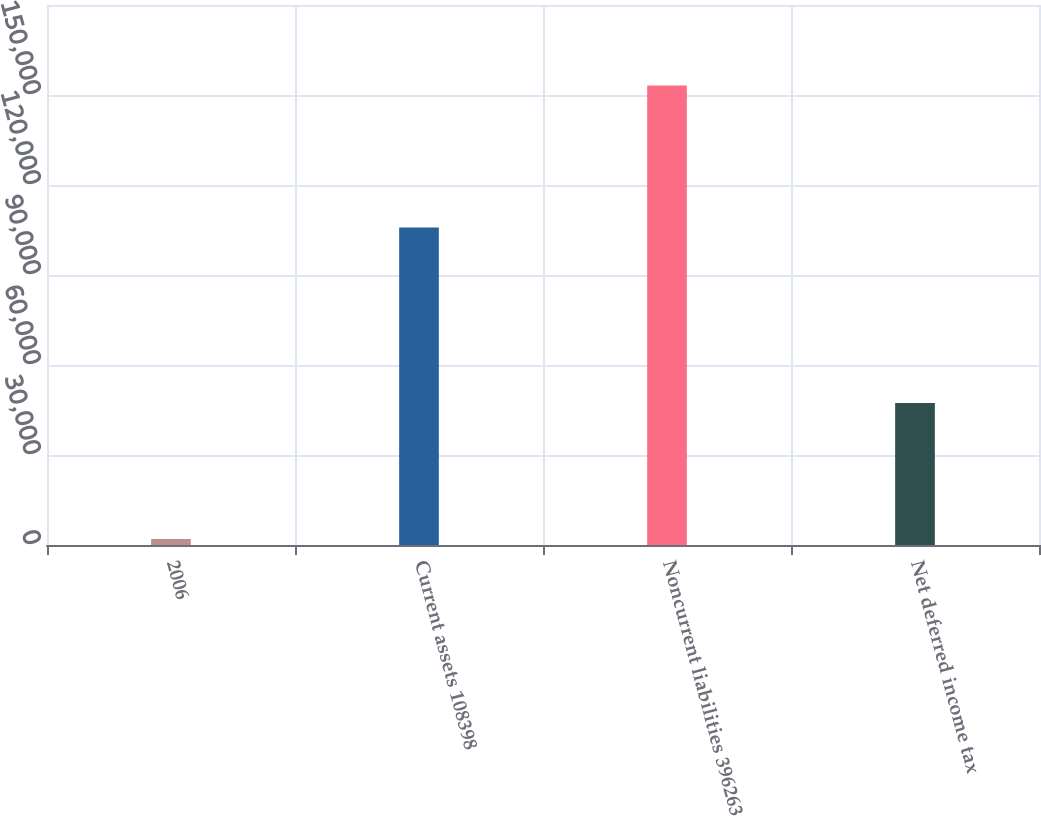<chart> <loc_0><loc_0><loc_500><loc_500><bar_chart><fcel>2006<fcel>Current assets 108398<fcel>Noncurrent liabilities 396263<fcel>Net deferred income tax<nl><fcel>2005<fcel>105845<fcel>153193<fcel>47348<nl></chart> 